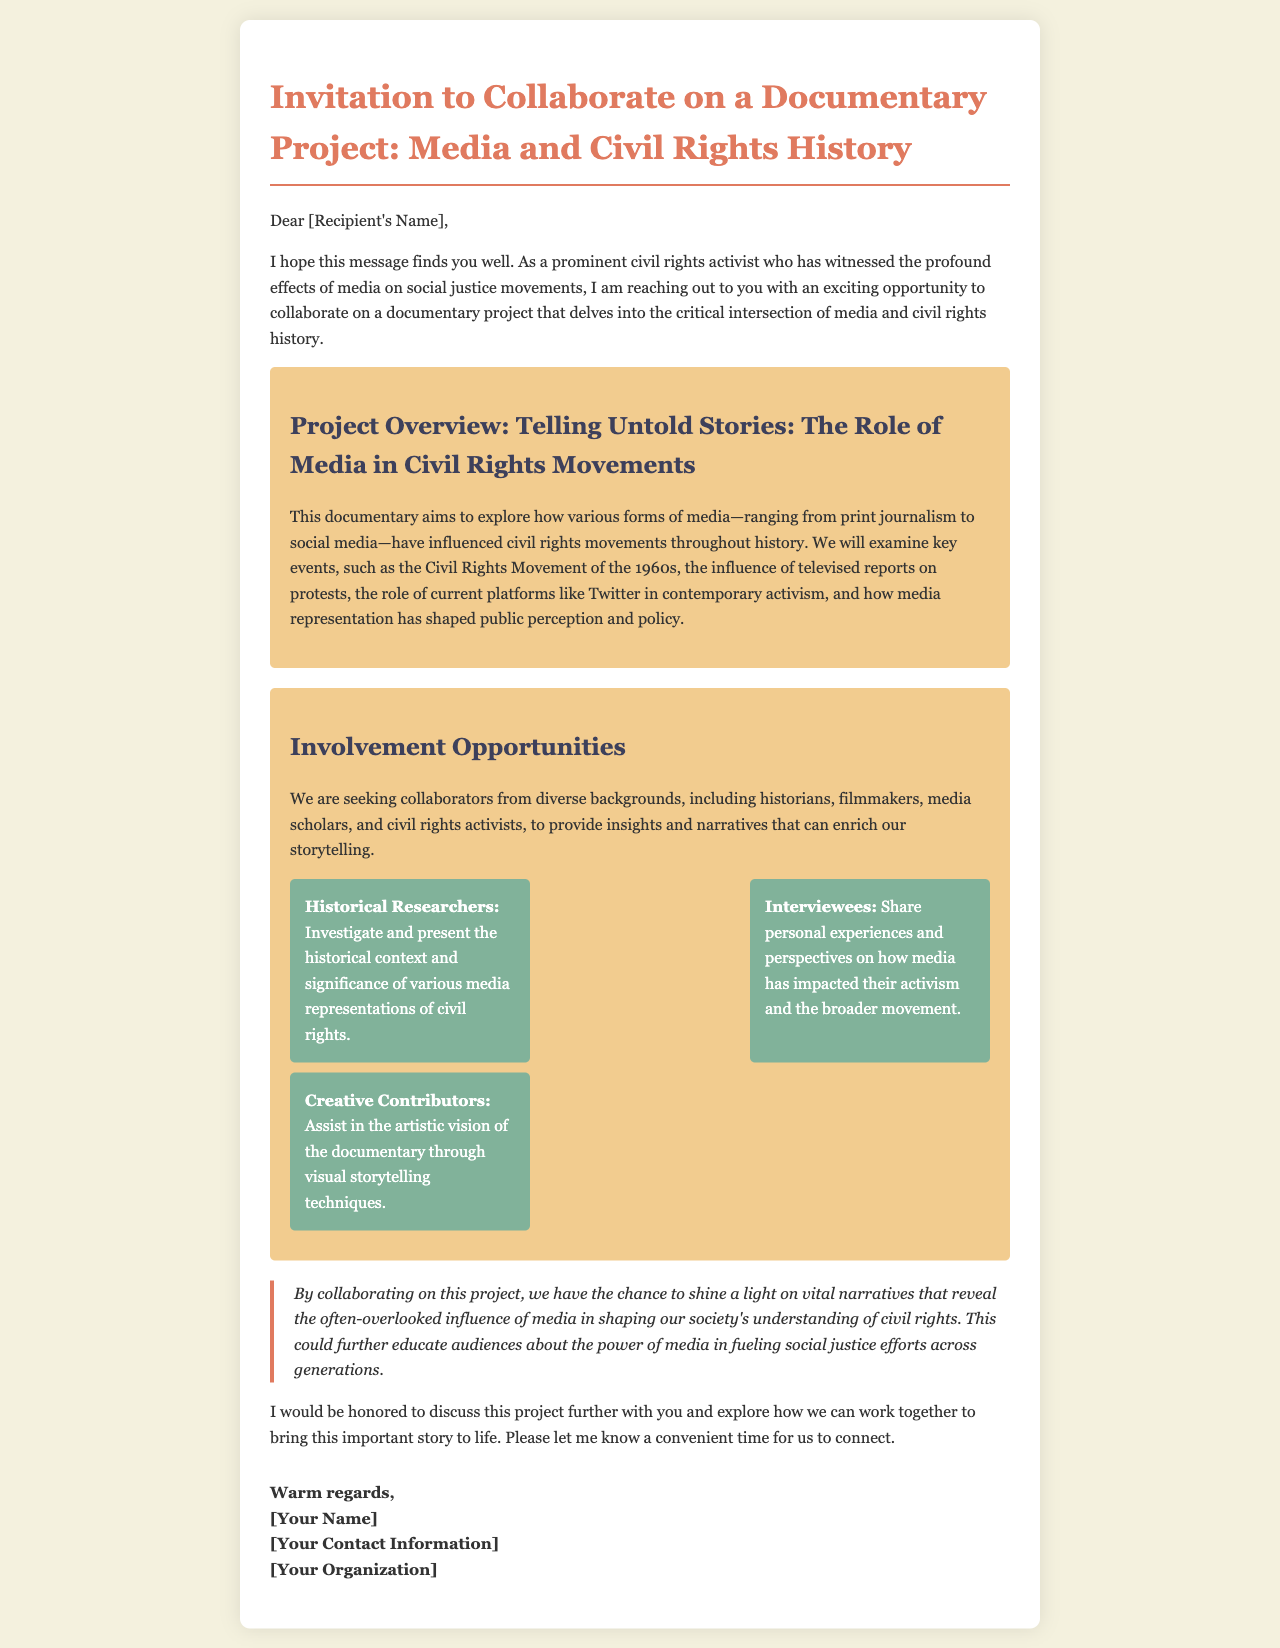What is the title of the documentary project? The title of the documentary project is specified in the document under the project overview section.
Answer: Telling Untold Stories: The Role of Media in Civil Rights Movements Who are the historical researchers? The historical researchers are specified as the role responsible for investigating and presenting the historical context of media representations of civil rights.
Answer: Investigate and present the historical context and significance of various media representations of civil rights What is the main focus of the documentary? The main focus is outlined in the project overview, highlighting the influence of media on civil rights movements throughout history.
Answer: How various forms of media have influenced civil rights movements throughout history Who should interested individuals contact to discuss collaboration? The document suggests contacting the sender for further discussion regarding collaboration on the project.
Answer: [Your Name] What is one key event mentioned in the documentary overview? The document explicitly mentions an important historical event connected to civil rights that will be discussed in the documentary.
Answer: The Civil Rights Movement of the 1960s What role involves sharing personal experiences? The document describes a specific role related to sharing narratives about media impact.
Answer: Interviewees How does the document suggest this project could educate audiences? The significance section of the document explains the potential impact of the project on audience knowledge about media's role in civil rights.
Answer: Shine a light on vital narratives that reveal the often-overlooked influence of media What is one current platform referenced in the documentary? The document mentions a contemporary platform that plays a role in current activism within the context of media.
Answer: Twitter 